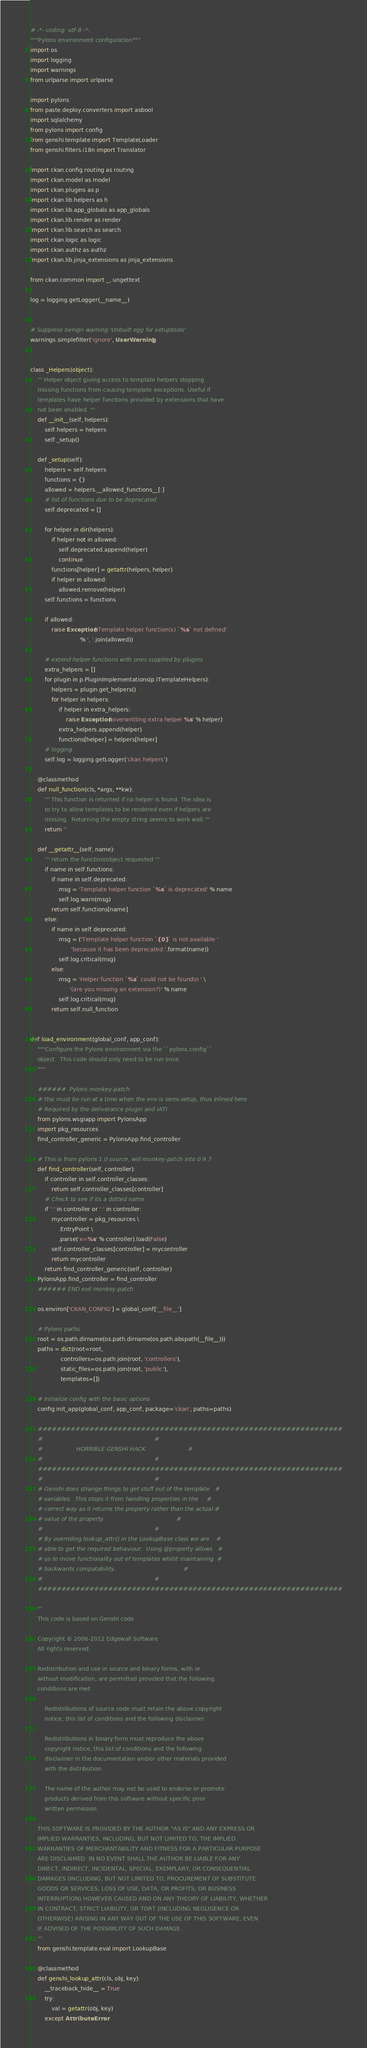<code> <loc_0><loc_0><loc_500><loc_500><_Python_># -*- coding: utf-8 -*-
"""Pylons environment configuration"""
import os
import logging
import warnings
from urlparse import urlparse

import pylons
from paste.deploy.converters import asbool
import sqlalchemy
from pylons import config
from genshi.template import TemplateLoader
from genshi.filters.i18n import Translator

import ckan.config.routing as routing
import ckan.model as model
import ckan.plugins as p
import ckan.lib.helpers as h
import ckan.lib.app_globals as app_globals
import ckan.lib.render as render
import ckan.lib.search as search
import ckan.logic as logic
import ckan.authz as authz
import ckan.lib.jinja_extensions as jinja_extensions

from ckan.common import _, ungettext

log = logging.getLogger(__name__)


# Suppress benign warning 'Unbuilt egg for setuptools'
warnings.simplefilter('ignore', UserWarning)


class _Helpers(object):
    ''' Helper object giving access to template helpers stopping
    missing functions from causing template exceptions. Useful if
    templates have helper functions provided by extensions that have
    not been enabled. '''
    def __init__(self, helpers):
        self.helpers = helpers
        self._setup()

    def _setup(self):
        helpers = self.helpers
        functions = {}
        allowed = helpers.__allowed_functions__[:]
        # list of functions due to be deprecated
        self.deprecated = []

        for helper in dir(helpers):
            if helper not in allowed:
                self.deprecated.append(helper)
                continue
            functions[helper] = getattr(helpers, helper)
            if helper in allowed:
                allowed.remove(helper)
        self.functions = functions

        if allowed:
            raise Exception('Template helper function(s) `%s` not defined'
                            % ', '.join(allowed))

        # extend helper functions with ones supplied by plugins
        extra_helpers = []
        for plugin in p.PluginImplementations(p.ITemplateHelpers):
            helpers = plugin.get_helpers()
            for helper in helpers:
                if helper in extra_helpers:
                    raise Exception('overwritting extra helper %s' % helper)
                extra_helpers.append(helper)
                functions[helper] = helpers[helper]
        # logging
        self.log = logging.getLogger('ckan.helpers')

    @classmethod
    def null_function(cls, *args, **kw):
        ''' This function is returned if no helper is found. The idea is
        to try to allow templates to be rendered even if helpers are
        missing.  Returning the empty string seems to work well.'''
        return ''

    def __getattr__(self, name):
        ''' return the function/object requested '''
        if name in self.functions:
            if name in self.deprecated:
                msg = 'Template helper function `%s` is deprecated' % name
                self.log.warn(msg)
            return self.functions[name]
        else:
            if name in self.deprecated:
                msg = ('Template helper function `{0}` is not available '
                       'because it has been deprecated.'.format(name))
                self.log.critical(msg)
            else:
                msg = 'Helper function `%s` could not be found\n ' \
                      '(are you missing an extension?)' % name
                self.log.critical(msg)
            return self.null_function


def load_environment(global_conf, app_conf):
    """Configure the Pylons environment via the ``pylons.config``
    object.  This code should only need to be run once.
    """

    ######  Pylons monkey-patch
    # this must be run at a time when the env is semi-setup, thus inlined here.
    # Required by the deliverance plugin and iATI
    from pylons.wsgiapp import PylonsApp
    import pkg_resources
    find_controller_generic = PylonsApp.find_controller

    # This is from pylons 1.0 source, will monkey-patch into 0.9.7
    def find_controller(self, controller):
        if controller in self.controller_classes:
            return self.controller_classes[controller]
        # Check to see if its a dotted name
        if '.' in controller or ':' in controller:
            mycontroller = pkg_resources \
                .EntryPoint \
                .parse('x=%s' % controller).load(False)
            self.controller_classes[controller] = mycontroller
            return mycontroller
        return find_controller_generic(self, controller)
    PylonsApp.find_controller = find_controller
    ###### END evil monkey-patch

    os.environ['CKAN_CONFIG'] = global_conf['__file__']

    # Pylons paths
    root = os.path.dirname(os.path.dirname(os.path.abspath(__file__)))
    paths = dict(root=root,
                 controllers=os.path.join(root, 'controllers'),
                 static_files=os.path.join(root, 'public'),
                 templates=[])

    # Initialize config with the basic options
    config.init_app(global_conf, app_conf, package='ckan', paths=paths)

    #################################################################
    #                                                               #
    #                   HORRIBLE GENSHI HACK                        #
    #                                                               #
    #################################################################
    #                                                               #
    # Genshi does strange things to get stuff out of the template   #
    # variables.  This stops it from handling properties in the     #
    # correct way as it returns the property rather than the actual #
    # value of the property.                                        #
    #                                                               #
    # By overriding lookup_attr() in the LookupBase class we are    #
    # able to get the required behaviour.  Using @property allows   #
    # us to move functionality out of templates whilst maintaining  #
    # backwards compatability.                                      #
    #                                                               #
    #################################################################

    '''
    This code is based on Genshi code

    Copyright © 2006-2012 Edgewall Software
    All rights reserved.

    Redistribution and use in source and binary forms, with or
    without modification, are permitted provided that the following
    conditions are met:

        Redistributions of source code must retain the above copyright
        notice, this list of conditions and the following disclaimer.

        Redistributions in binary form must reproduce the above
        copyright notice, this list of conditions and the following
        disclaimer in the documentation and/or other materials provided
        with the distribution.

        The name of the author may not be used to endorse or promote
        products derived from this software without specific prior
        written permission.

    THIS SOFTWARE IS PROVIDED BY THE AUTHOR "AS IS" AND ANY EXPRESS OR
    IMPLIED WARRANTIES, INCLUDING, BUT NOT LIMITED TO, THE IMPLIED
    WARRANTIES OF MERCHANTABILITY AND FITNESS FOR A PARTICULAR PURPOSE
    ARE DISCLAIMED. IN NO EVENT SHALL THE AUTHOR BE LIABLE FOR ANY
    DIRECT, INDIRECT, INCIDENTAL, SPECIAL, EXEMPLARY, OR CONSEQUENTIAL
    DAMAGES (INCLUDING, BUT NOT LIMITED TO, PROCUREMENT OF SUBSTITUTE
    GOODS OR SERVICES; LOSS OF USE, DATA, OR PROFITS; OR BUSINESS
    INTERRUPTION) HOWEVER CAUSED AND ON ANY THEORY OF LIABILITY, WHETHER
    IN CONTRACT, STRICT LIABILITY, OR TORT (INCLUDING NEGLIGENCE OR
    OTHERWISE) ARISING IN ANY WAY OUT OF THE USE OF THIS SOFTWARE, EVEN
    IF ADVISED OF THE POSSIBILITY OF SUCH DAMAGE.
    '''
    from genshi.template.eval import LookupBase

    @classmethod
    def genshi_lookup_attr(cls, obj, key):
        __traceback_hide__ = True
        try:
            val = getattr(obj, key)
        except AttributeError:</code> 